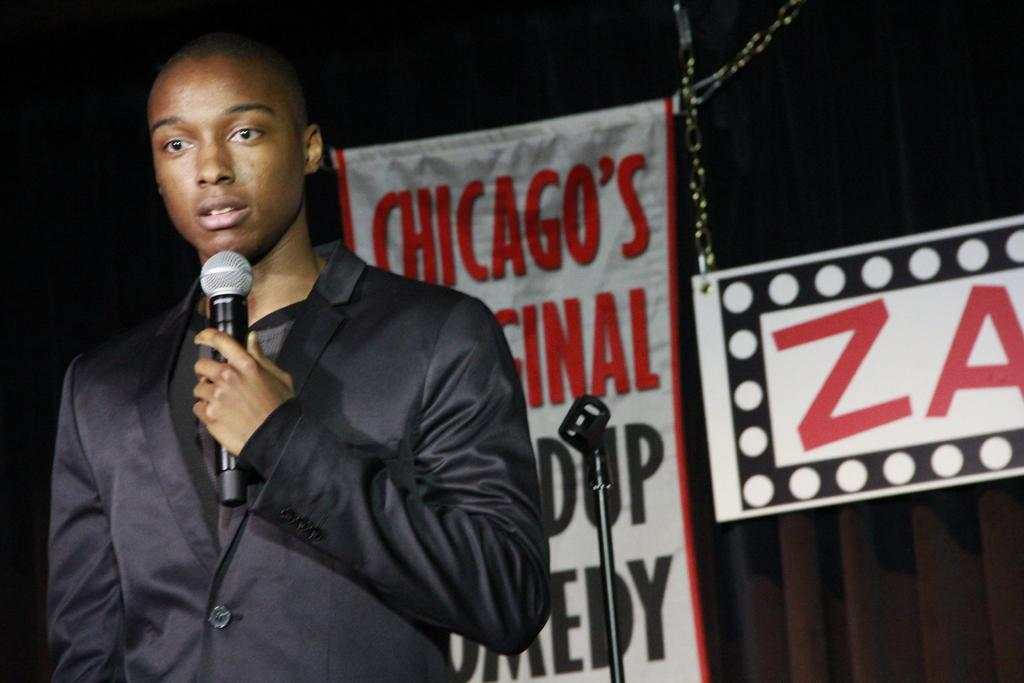What is the main subject of the image? There is a person in the image. What is the person wearing? The person is wearing a black blazer. What is the person doing in the image? The person is standing and holding a microphone in his hand. What can be seen in the background of the image? There is a name board and a banner in the background of the image. What type of cake is being served at the scarecrow's birthday party in the image? There is no scarecrow or cake present in the image. How much money is being exchanged between the person and the audience in the image? There is no indication of money being exchanged in the image. 